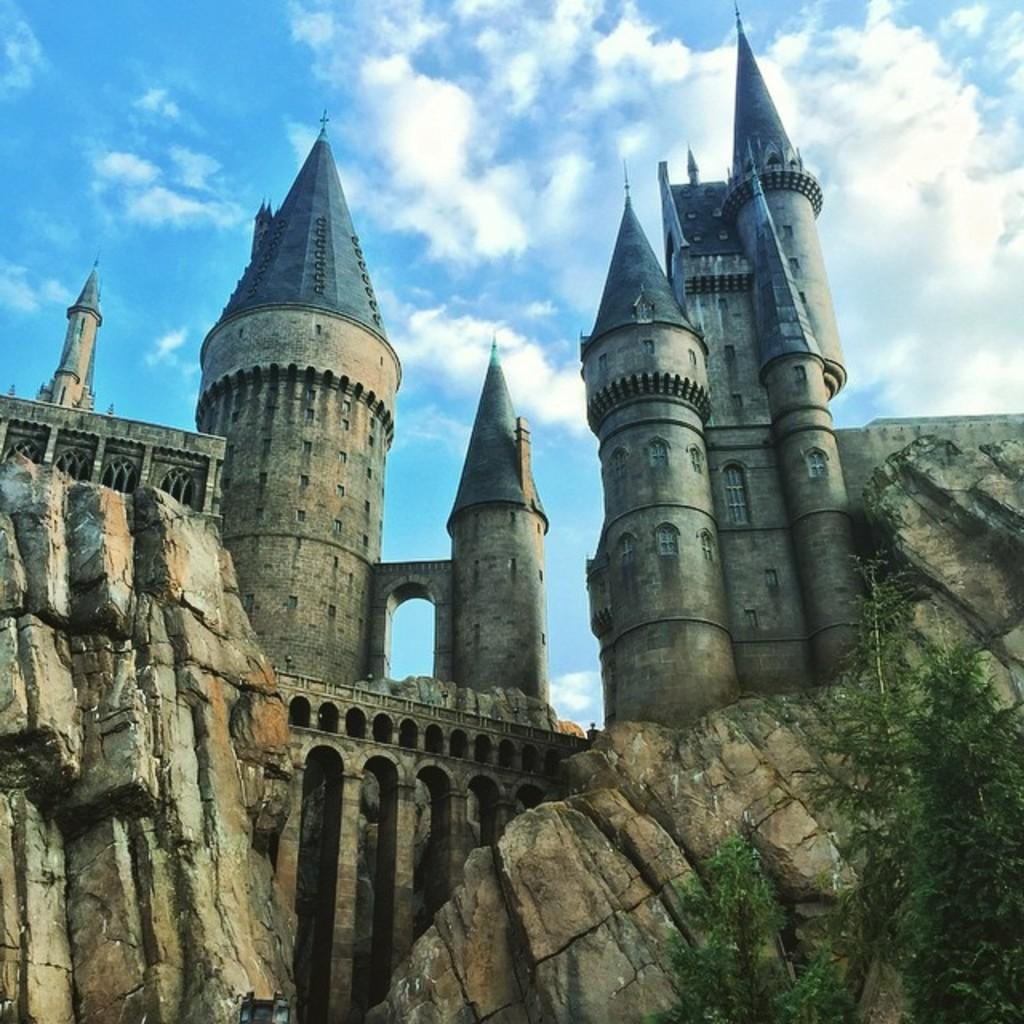What type of structure is visible in the image? There is a fort in the image. What natural elements can be seen in the image? There are rocks and trees visible in the image. What is visible in the background of the image? The sky is visible in the background of the image. What can be observed in the sky? Clouds are present in the sky. How many hands are holding the bell in the image? There is no bell present in the image, so it is not possible to determine how many hands might be holding it. 